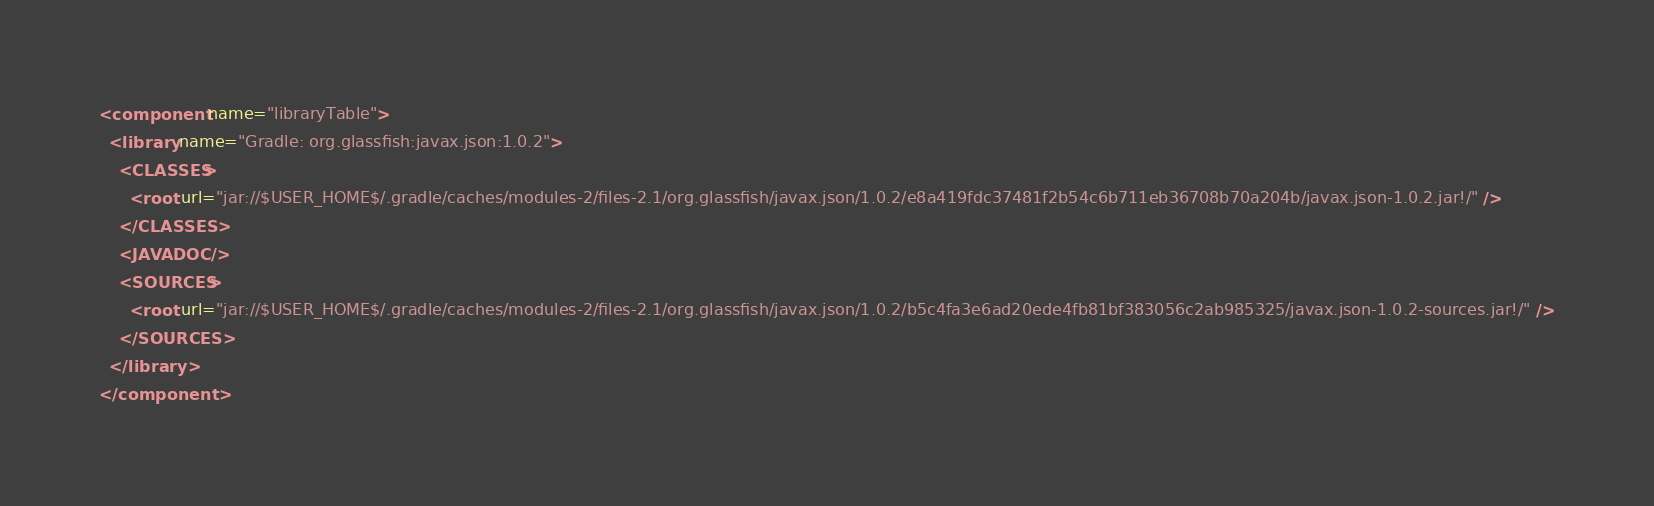<code> <loc_0><loc_0><loc_500><loc_500><_XML_><component name="libraryTable">
  <library name="Gradle: org.glassfish:javax.json:1.0.2">
    <CLASSES>
      <root url="jar://$USER_HOME$/.gradle/caches/modules-2/files-2.1/org.glassfish/javax.json/1.0.2/e8a419fdc37481f2b54c6b711eb36708b70a204b/javax.json-1.0.2.jar!/" />
    </CLASSES>
    <JAVADOC />
    <SOURCES>
      <root url="jar://$USER_HOME$/.gradle/caches/modules-2/files-2.1/org.glassfish/javax.json/1.0.2/b5c4fa3e6ad20ede4fb81bf383056c2ab985325/javax.json-1.0.2-sources.jar!/" />
    </SOURCES>
  </library>
</component></code> 